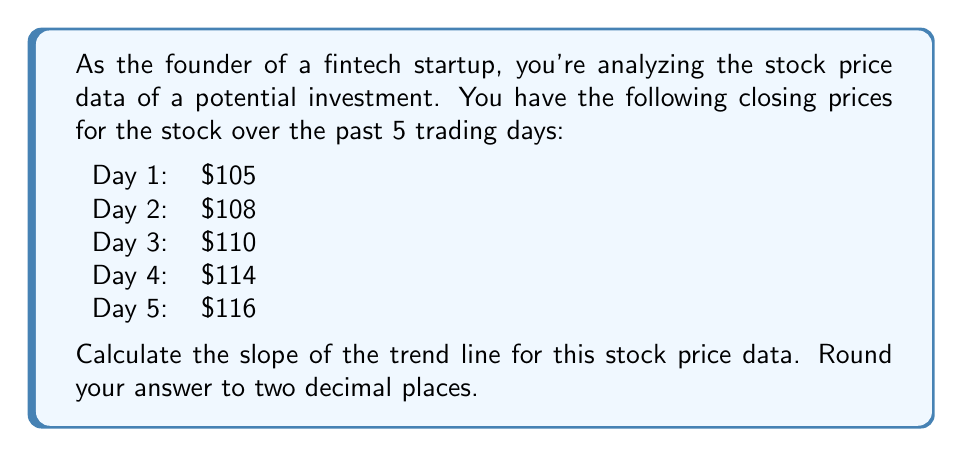Could you help me with this problem? To calculate the slope of the trend line, we'll use the formula for the slope in a linear regression model:

$$ m = \frac{n\sum xy - \sum x \sum y}{n\sum x^2 - (\sum x)^2} $$

Where:
$m$ is the slope
$n$ is the number of data points
$x$ represents the days (1, 2, 3, 4, 5)
$y$ represents the stock prices

Let's calculate each component:

1) $n = 5$ (5 data points)

2) $\sum x = 1 + 2 + 3 + 4 + 5 = 15$

3) $\sum y = 105 + 108 + 110 + 114 + 116 = 553$

4) $\sum xy = (1 \times 105) + (2 \times 108) + (3 \times 110) + (4 \times 114) + (5 \times 116) = 1,719$

5) $\sum x^2 = 1^2 + 2^2 + 3^2 + 4^2 + 5^2 = 55$

Now, let's plug these values into the slope formula:

$$ m = \frac{5(1,719) - 15(553)}{5(55) - 15^2} $$

$$ m = \frac{8,595 - 8,295}{275 - 225} $$

$$ m = \frac{300}{50} = 6 $$

Therefore, the slope of the trend line is 6.
Answer: $6.00$ 